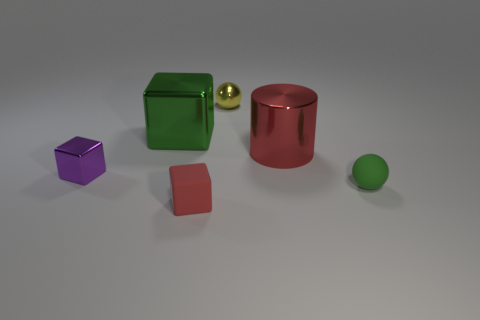Subtract all small blocks. How many blocks are left? 1 Subtract all green balls. How many balls are left? 1 Subtract all spheres. How many objects are left? 4 Add 1 red balls. How many objects exist? 7 Subtract 1 spheres. How many spheres are left? 1 Subtract all gray spheres. How many green blocks are left? 1 Subtract all big brown shiny things. Subtract all green metal objects. How many objects are left? 5 Add 4 shiny things. How many shiny things are left? 8 Add 3 big gray matte cylinders. How many big gray matte cylinders exist? 3 Subtract 0 brown balls. How many objects are left? 6 